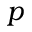<formula> <loc_0><loc_0><loc_500><loc_500>p</formula> 